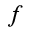Convert formula to latex. <formula><loc_0><loc_0><loc_500><loc_500>f</formula> 